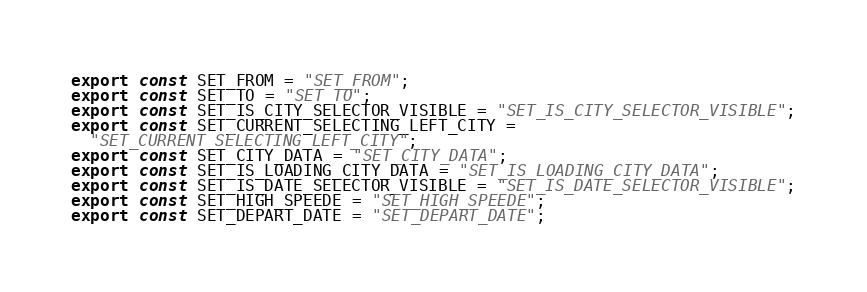<code> <loc_0><loc_0><loc_500><loc_500><_JavaScript_>export const SET_FROM = "SET_FROM";
export const SET_TO = "SET_TO";
export const SET_IS_CITY_SELECTOR_VISIBLE = "SET_IS_CITY_SELECTOR_VISIBLE";
export const SET_CURRENT_SELECTING_LEFT_CITY =
  "SET_CURRENT_SELECTING_LEFT_CITY";
export const SET_CITY_DATA = "SET_CITY_DATA";
export const SET_IS_LOADING_CITY_DATA = "SET_IS_LOADING_CITY_DATA";
export const SET_IS_DATE_SELECTOR_VISIBLE = "SET_IS_DATE_SELECTOR_VISIBLE";
export const SET_HIGH_SPEEDE = "SET_HIGH_SPEEDE";
export const SET_DEPART_DATE = "SET_DEPART_DATE";
</code> 